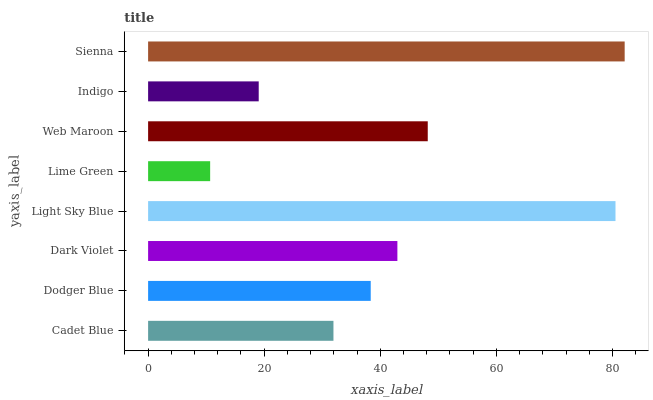Is Lime Green the minimum?
Answer yes or no. Yes. Is Sienna the maximum?
Answer yes or no. Yes. Is Dodger Blue the minimum?
Answer yes or no. No. Is Dodger Blue the maximum?
Answer yes or no. No. Is Dodger Blue greater than Cadet Blue?
Answer yes or no. Yes. Is Cadet Blue less than Dodger Blue?
Answer yes or no. Yes. Is Cadet Blue greater than Dodger Blue?
Answer yes or no. No. Is Dodger Blue less than Cadet Blue?
Answer yes or no. No. Is Dark Violet the high median?
Answer yes or no. Yes. Is Dodger Blue the low median?
Answer yes or no. Yes. Is Web Maroon the high median?
Answer yes or no. No. Is Web Maroon the low median?
Answer yes or no. No. 